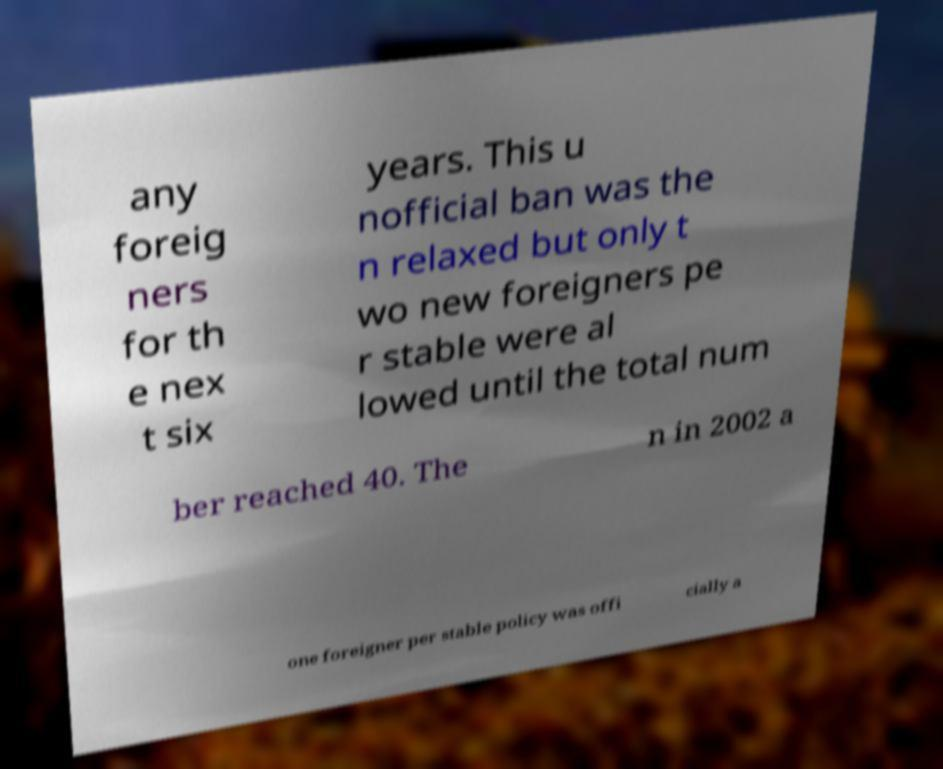Please identify and transcribe the text found in this image. any foreig ners for th e nex t six years. This u nofficial ban was the n relaxed but only t wo new foreigners pe r stable were al lowed until the total num ber reached 40. The n in 2002 a one foreigner per stable policy was offi cially a 